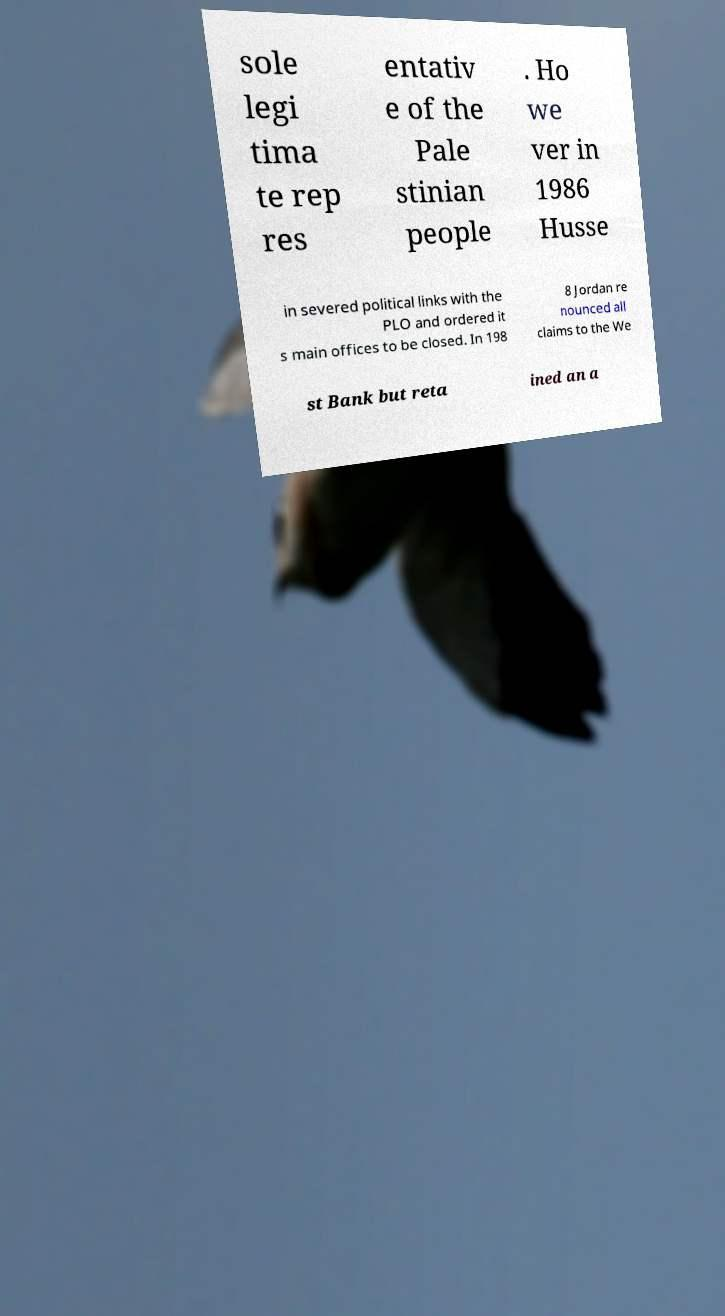Please identify and transcribe the text found in this image. sole legi tima te rep res entativ e of the Pale stinian people . Ho we ver in 1986 Husse in severed political links with the PLO and ordered it s main offices to be closed. In 198 8 Jordan re nounced all claims to the We st Bank but reta ined an a 